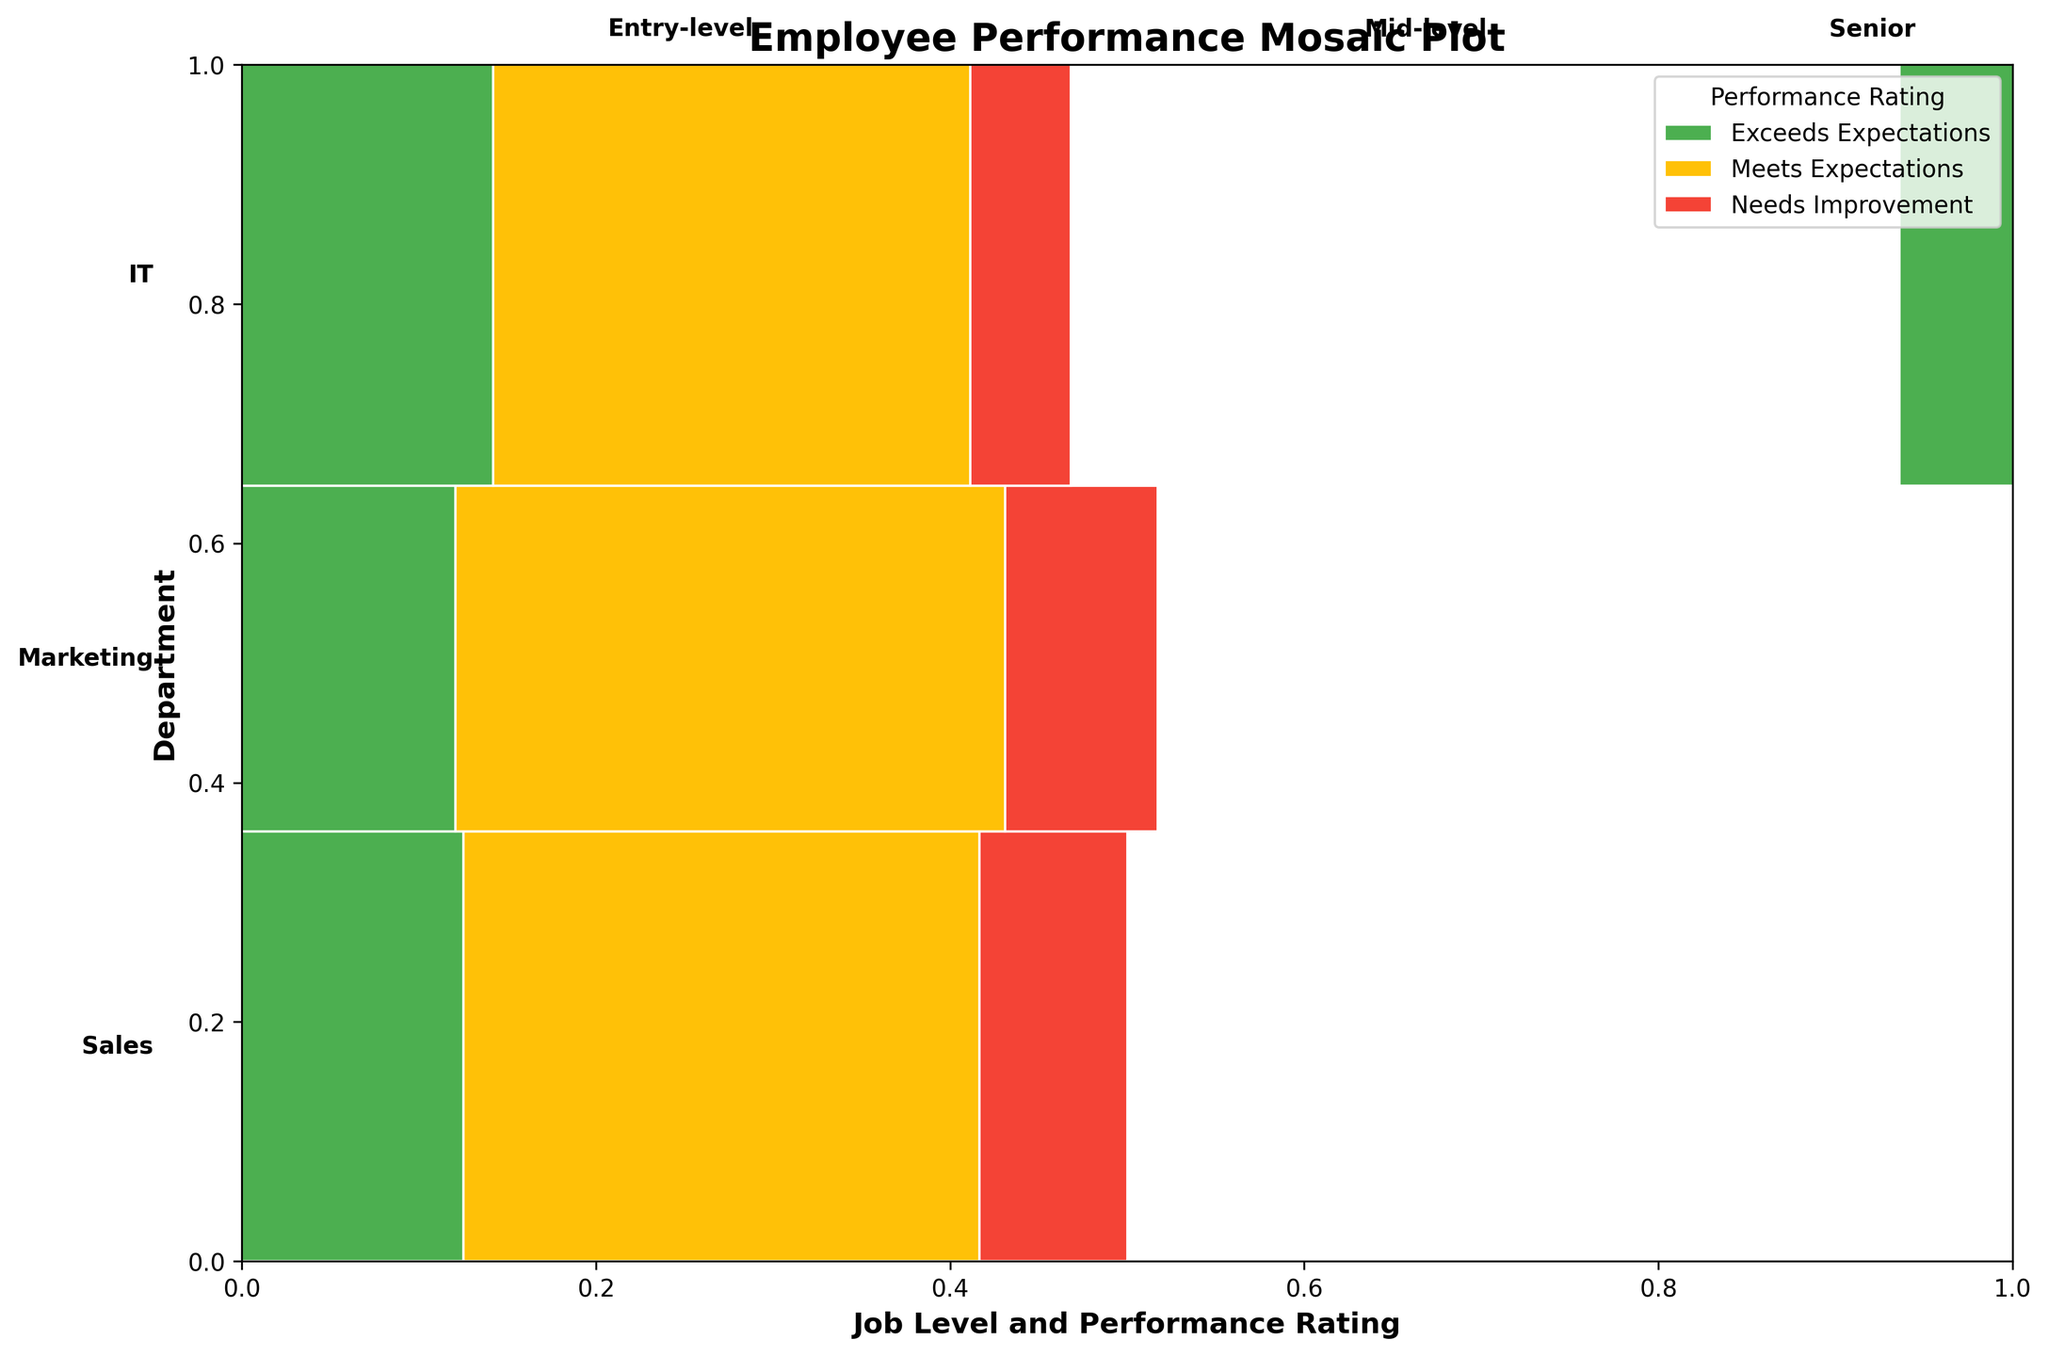What's the title of the figure? The title of the figure is typically displayed at the top and is a brief description of what the figure represents. In this case, the title is clearly stated as "Employee Performance Mosaic Plot".
Answer: Employee Performance Mosaic Plot What colors are used to represent the performance ratings? In the figure, different colors are used to represent different performance ratings. Green represents "Exceeds Expectations", yellow represents "Meets Expectations", and red represents "Needs Improvement".
Answer: Green, yellow, red Which department has the largest area in the plot? The areas in the mosaic plot are proportionate to the counts (number of employees). The largest area corresponds to the department with the highest total count of employees. Visually, Sales appears to have the largest area.
Answer: Sales For the Sales department, which job level has the highest proportion of "Exceeds Expectations" ratings? Within the Sales department, look at the different job levels and identify which level's rectangle has the largest green section. The Entry-level job in Sales has the largest green area, representing the highest proportion of "Exceeds Expectations" ratings.
Answer: Entry-level Compare the proportions of "Needs Improvement" ratings between Entry-level employees in Sales and IT departments. In the plot, compare the red sections for Entry-level employees across Sales and IT departments. The red area is smaller in IT compared to Sales, indicating that Entry-level employees in Sales have a higher proportion of "Needs Improvement" ratings than those in IT.
Answer: Sales is higher Which job level in Marketing has the smallest proportion of "Needs Improvement" ratings? Within the Marketing department, look at the red sections for different job levels. The Senior level in Marketing has the smallest red section, indicating the smallest proportion of "Needs Improvement" ratings.
Answer: Senior Is there any job level in IT where the proportion of "Exceeds Expectations" ratings is higher than the proportion of "Meets Expectations"? In the IT department, examine the green and yellow areas for each job level. For all job levels in IT, the yellow area ("Meets Expectations") is larger than the green area ("Exceeds Expectations"). Therefore, no job level in IT has a higher proportion of "Exceeds Expectations" ratings than "Meets Expectations".
Answer: No What is the overall trend in performance ratings as the job level increases in the Sales department? Observe the changes in the proportions of colors (green, yellow, red) for the Sales department from Entry-level to Mid-level to Senior. As the job level increases, the proportion of "Meets Expectations" increases, and the proportions of both "Exceeds Expectations" and "Needs Improvement" decrease.
Answer: "Meets Expectations" increases, others decrease Between the departments, which one has the highest proportion of "Meets Expectations" ratings at the Mid-level job? Compare the yellow sections within the Mid-level job levels across departments. The Sales department has the highest proportion of yellow within the Mid-level job category.
Answer: Sales 